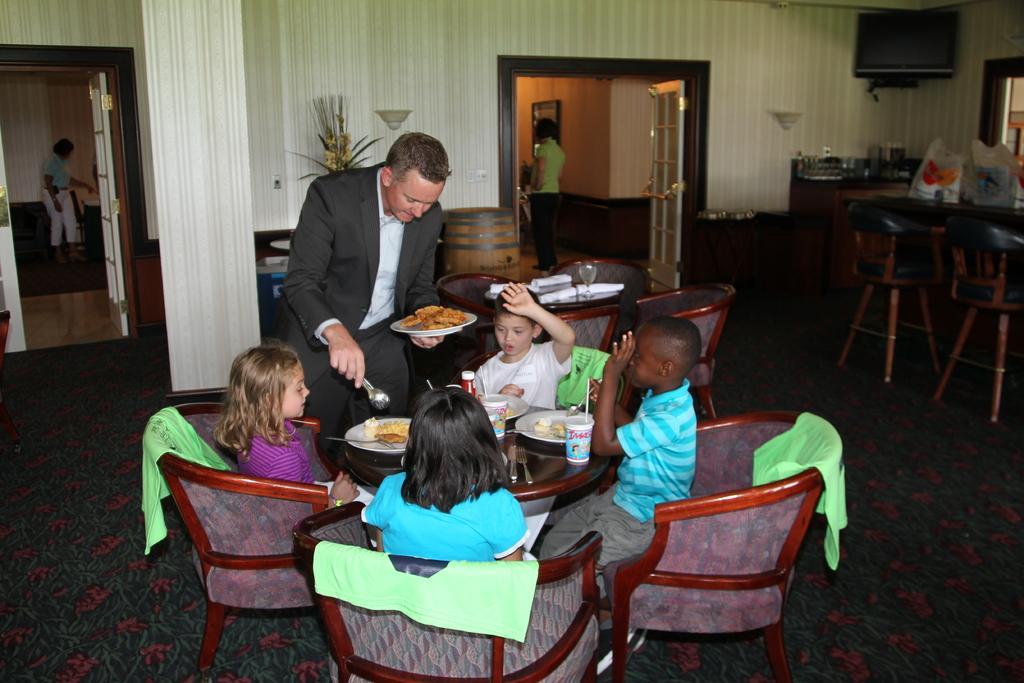Describe this image in one or two sentences. In this image there are four children sitting on the chairs and one man is standing and he is holding a plate and some food in it. On the other hand he is holding a spoon. In this image there are four chairs and one table. On the table there are three plates and one glass. On the right side there is one table and two chairs and there are two carry bags on the table. On the top of the right corner there is one monitor and in the middle of the image there is one door and there is one woman is standing and there is one photo frame on the left side there is one door and one woman who is standing. In the middle of the image there is one flower pot. On the middle of the image there are another four chairs and one table and on the table there is one glass and some handkerchiefs 